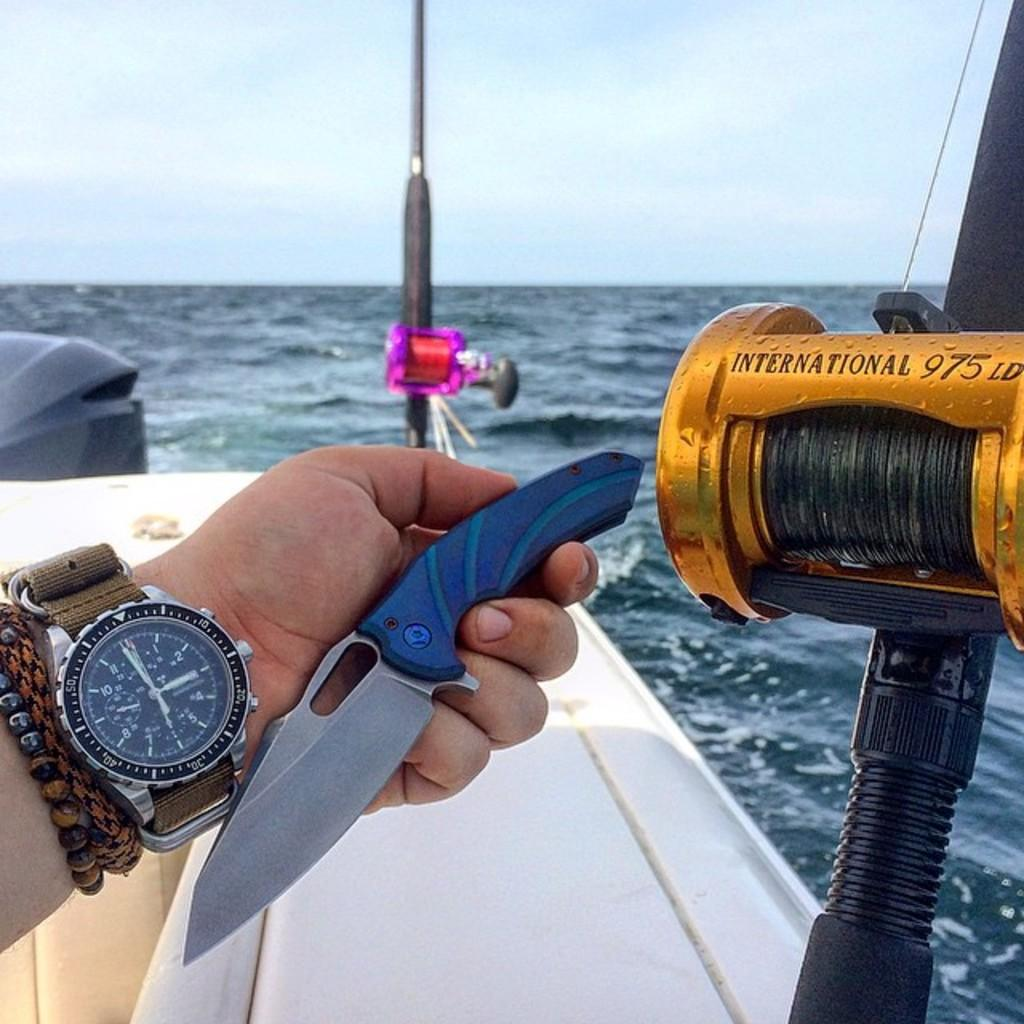Provide a one-sentence caption for the provided image. A man is holding a knife in his hand while fishing at 2:59 pm. 